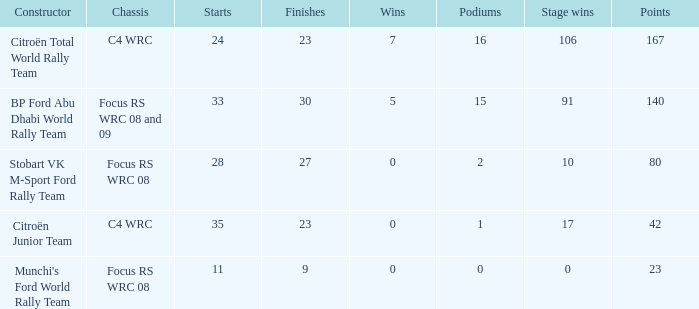What is the maximum podiums when the stage victories are 91 and the points are below 140? None. 